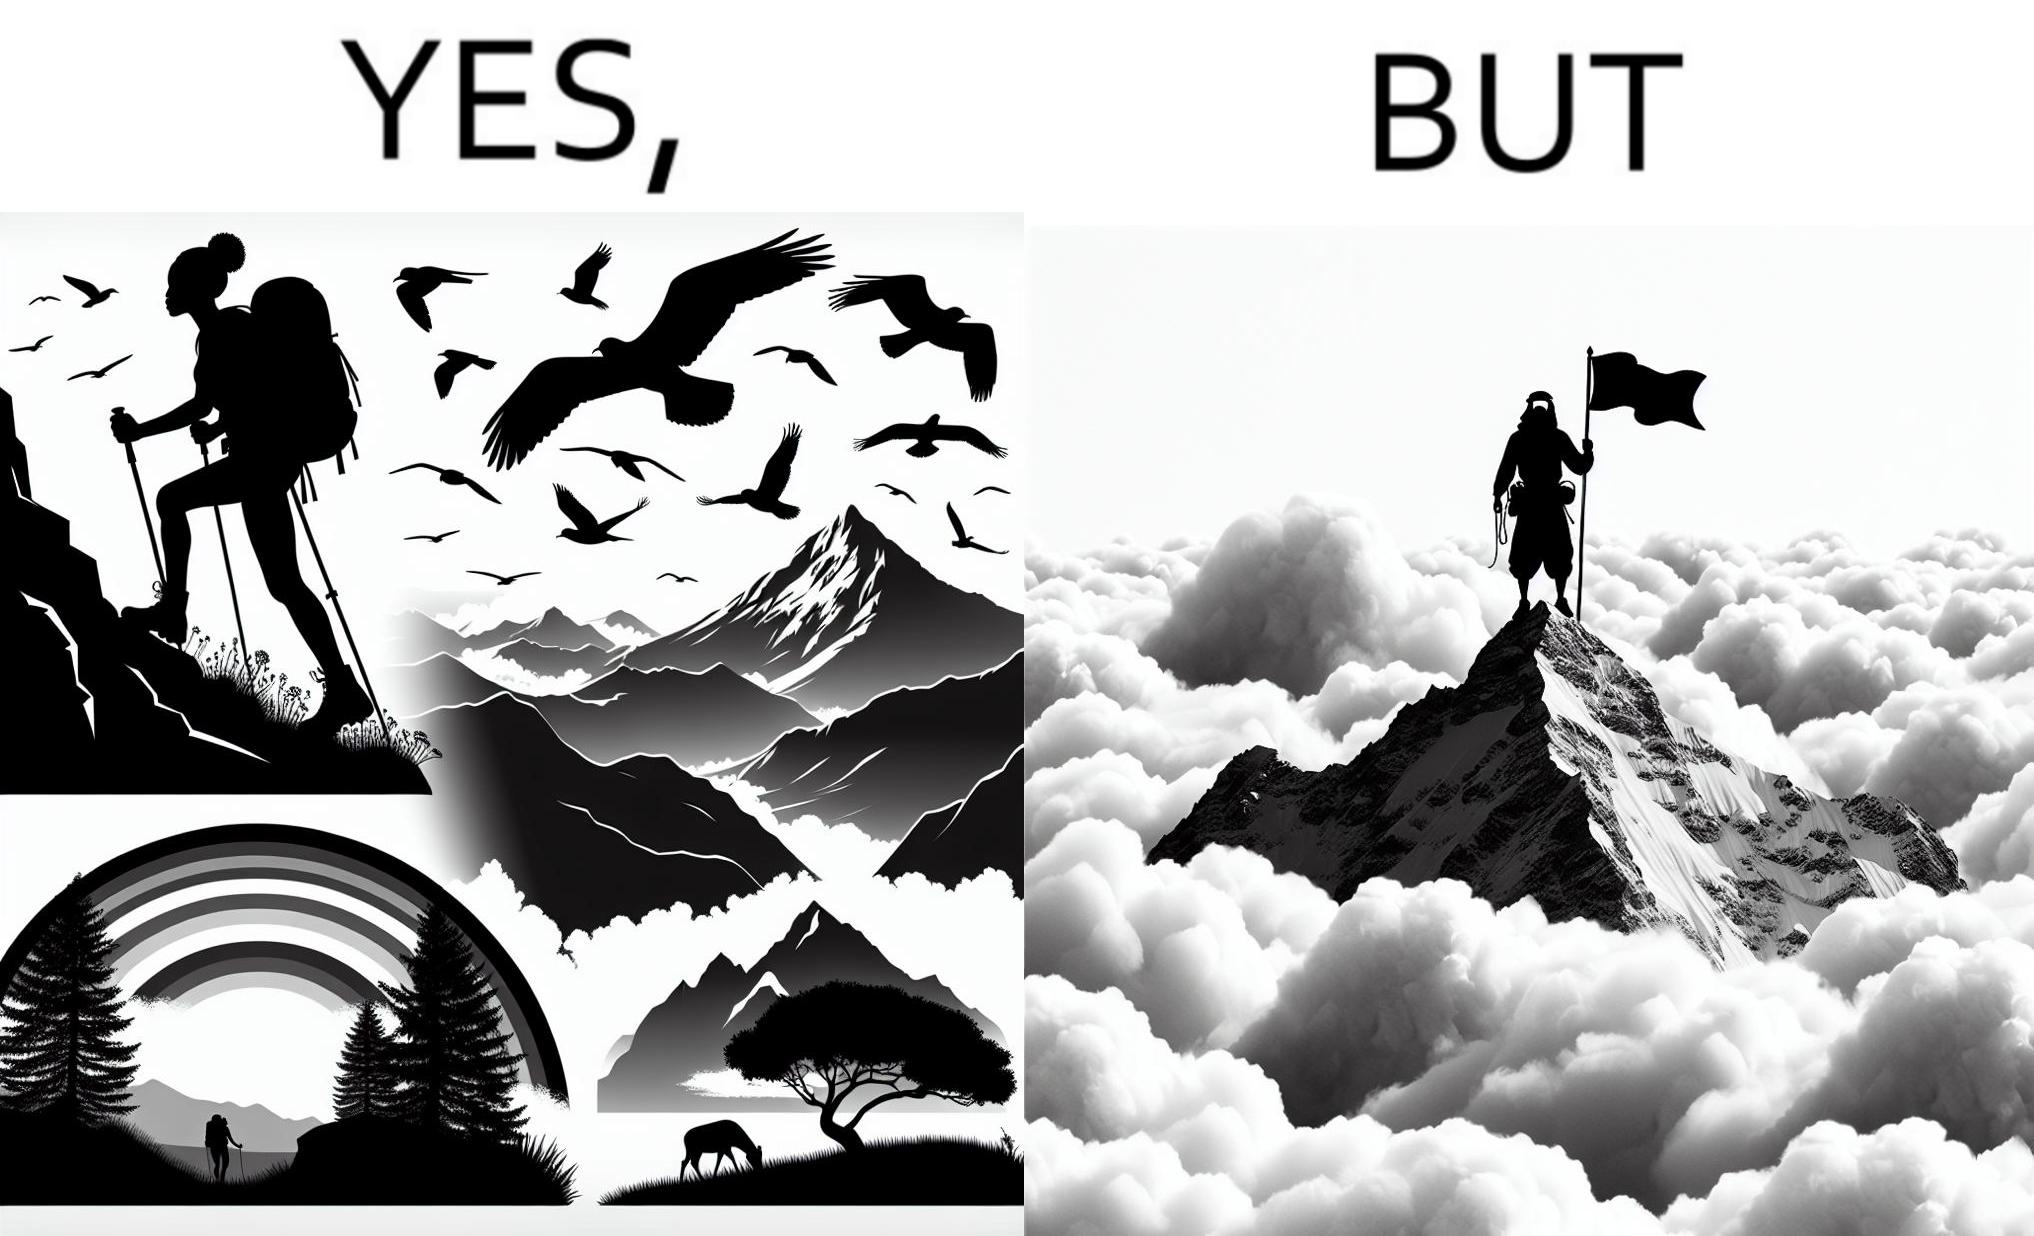Describe the satirical element in this image. The image is ironic, because the mountaineer climbs up the mountain to view the world from the peak but due to so much cloud, at the top, nothing is visible whereas he was able to witness some awesome views while climbing up the mountain 